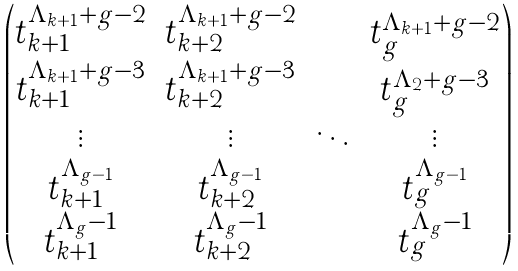<formula> <loc_0><loc_0><loc_500><loc_500>\begin{pmatrix} t _ { k + 1 } ^ { \Lambda _ { k + 1 } + g - 2 } & t _ { k + 2 } ^ { \Lambda _ { k + 1 } + g - 2 } & \cdots & t _ { g } ^ { \Lambda _ { k + 1 } + g - 2 } \\ t _ { k + 1 } ^ { \Lambda _ { k + 1 } + g - 3 } & t _ { k + 2 } ^ { \Lambda _ { k + 1 } + g - 3 } & \cdots & t _ { g } ^ { \Lambda _ { 2 } + g - 3 } \\ \vdots & \vdots & \ddots & \vdots \\ t _ { k + 1 } ^ { \Lambda _ { g - 1 } } & t _ { k + 2 } ^ { \Lambda _ { g - 1 } } & \cdots & t _ { g } ^ { \Lambda _ { g - 1 } } \\ t _ { k + 1 } ^ { \Lambda _ { g } - 1 } & t _ { k + 2 } ^ { \Lambda _ { g } - 1 } & \cdots & t _ { g } ^ { \Lambda _ { g } - 1 } \\ \end{pmatrix}</formula> 